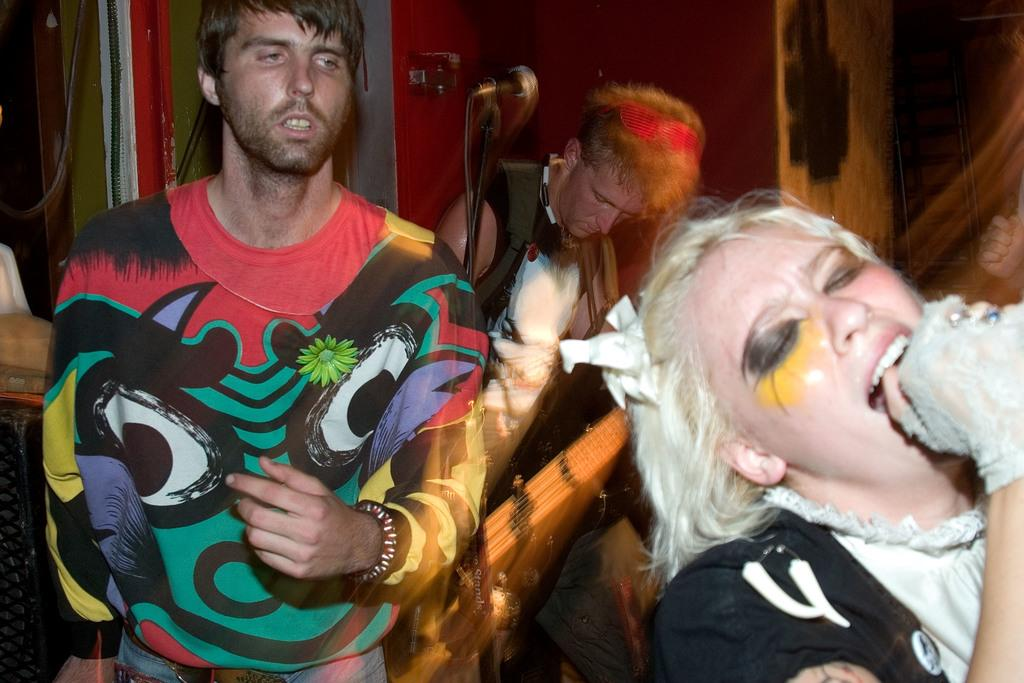How many people are in the image? There are three people in the image. What is the man holding in the image? The man is holding a guitar and a mic. What can be seen in the background of the image? There are wires and a wall visible in the background. How does the grass increase in the image? There is no grass present in the image, so it cannot increase. 